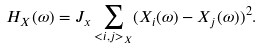<formula> <loc_0><loc_0><loc_500><loc_500>H _ { X } ( \omega ) = J _ { x } \sum _ { < i , j > _ { X } } ( X _ { i } ( \omega ) - X _ { j } ( \omega ) ) ^ { 2 } .</formula> 